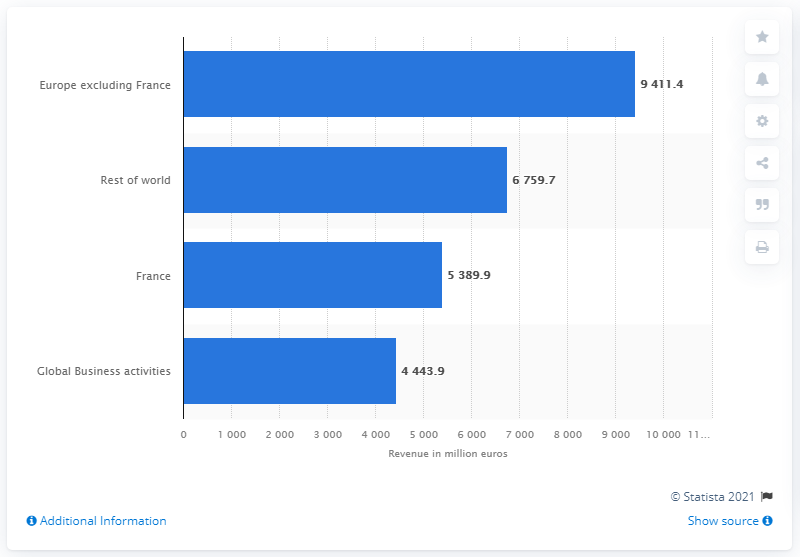Draw attention to some important aspects in this diagram. Veolia generated a revenue of 9411.4 in the rest of Europe in fiscal year 2020. 